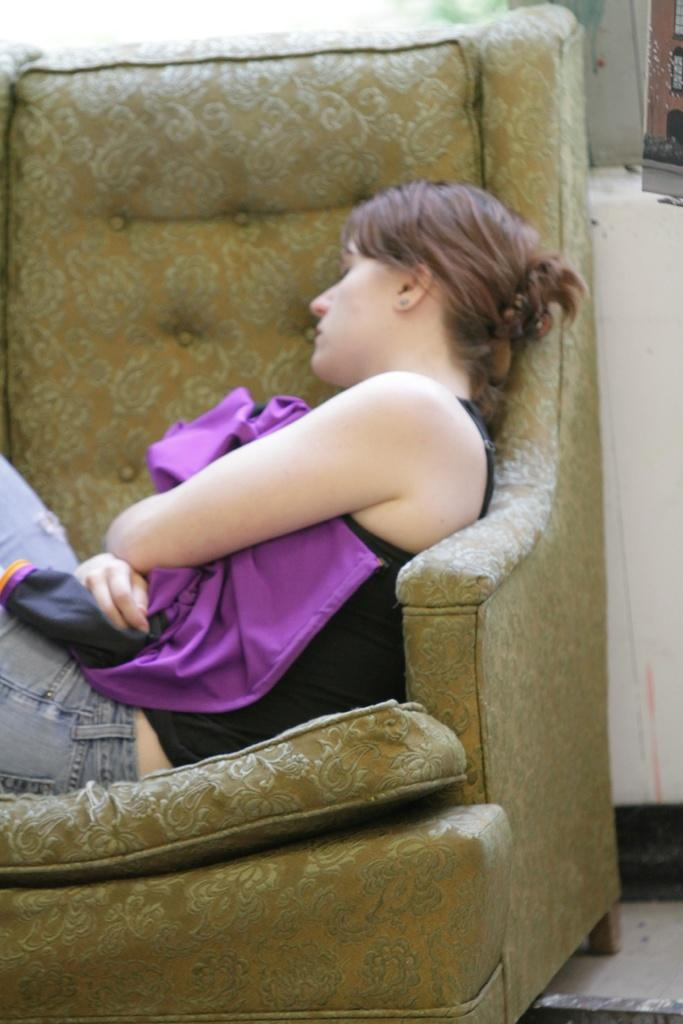Who is present in the image? There is a woman in the image. What is the woman doing in the image? The woman is sleeping on a sofa. What color is the wall in the image? The wall in the image is painted with cream color. What can be seen beneath the woman in the image? The floor is visible in the image. What type of guitar is being advertised on the plate in the image? There is no guitar or plate present in the image. 